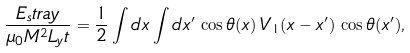Convert formula to latex. <formula><loc_0><loc_0><loc_500><loc_500>\frac { E _ { s } t r a y } { \mu _ { 0 } M ^ { 2 } L _ { y } t } = \frac { 1 } { 2 } \int d x \int d x ^ { \prime } \, \cos { \theta ( x ) } \, V _ { 1 } ( x - x ^ { \prime } ) \, \cos { \theta ( x ^ { \prime } ) } ,</formula> 